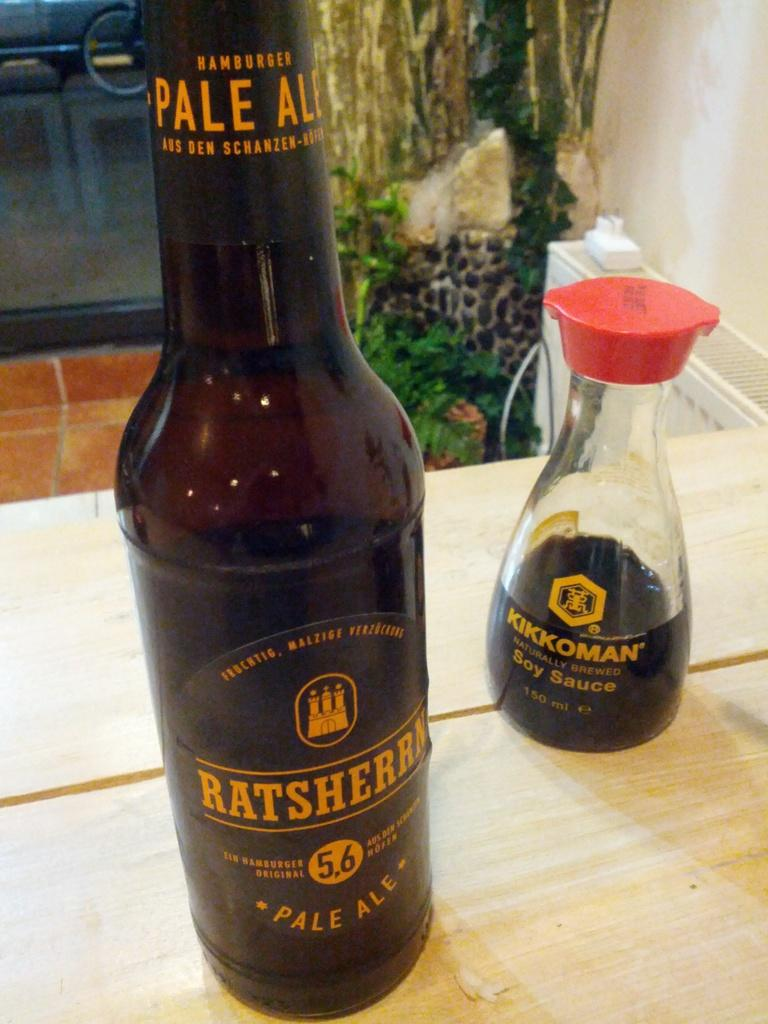<image>
Write a terse but informative summary of the picture. Bottle of ratsherrn sits next to a bottle of soy sauce on the table. 